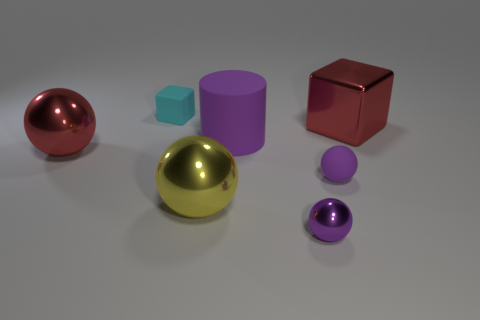Subtract 1 cylinders. How many cylinders are left? 0 Add 2 large red shiny balls. How many objects exist? 9 Subtract all purple balls. How many balls are left? 2 Subtract all red spheres. How many spheres are left? 3 Subtract all large objects. Subtract all red balls. How many objects are left? 2 Add 7 large cubes. How many large cubes are left? 8 Add 3 big red metallic spheres. How many big red metallic spheres exist? 4 Subtract 0 yellow cylinders. How many objects are left? 7 Subtract all balls. How many objects are left? 3 Subtract all yellow blocks. Subtract all brown cylinders. How many blocks are left? 2 